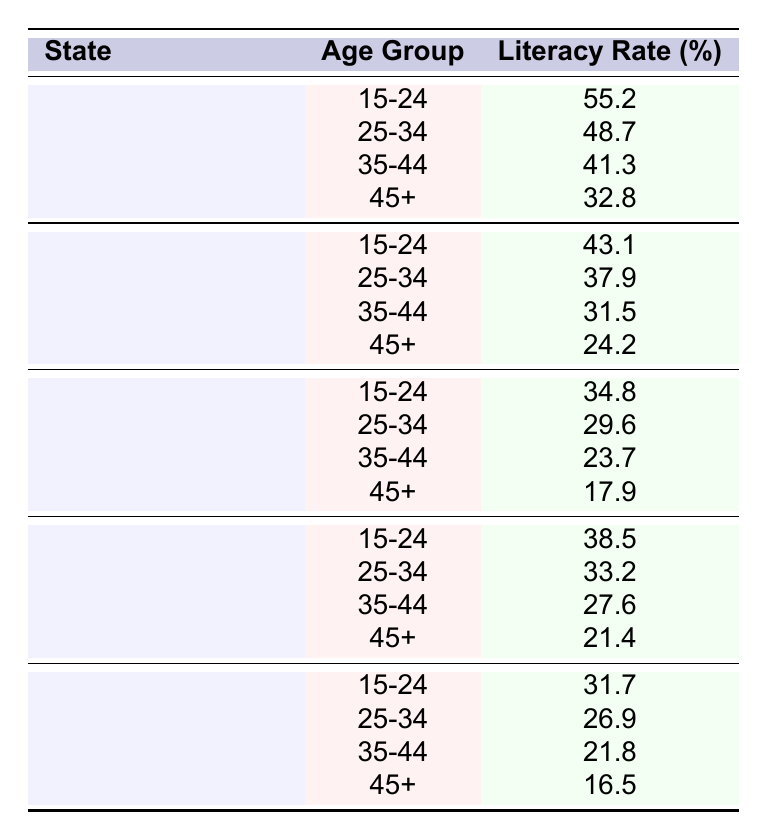What is the literacy rate for the age group 15-24 in Central Equatoria? According to the table, the literacy rate for the age group 15-24 in Central Equatoria is explicitly given as 55.2%.
Answer: 55.2% Which state has the highest literacy rate for the age group 25-34? By comparing the literacy rates for the age group 25-34 from all states, I observe that Central Equatoria has the highest rate at 48.7%.
Answer: Central Equatoria What is the literacy rate difference between the age groups 35-44 and 45+ in Western Equatoria? The literacy rate for age group 35-44 in Western Equatoria is 31.5%, and for 45+, it is 24.2%. The difference is calculated as 31.5 - 24.2 = 7.3%.
Answer: 7.3% Which state has the lowest literacy rate in the age group 45+? Jonglei has the lowest literacy rate for the age group 45+ at 17.9%.
Answer: Jonglei What is the average literacy rate for the age group 15-24 across all states? I calculate the average by adding the literacy rates for the age group 15-24: 55.2 (Central Equatoria) + 43.1 (Western Equatoria) + 34.8 (Jonglei) + 38.5 (Upper Nile) + 31.7 (Unity) = 203.3. Since there are 5 states, the average is 203.3 / 5 = 40.66%.
Answer: 40.66% Is the literacy rate for the age group 25-34 in Upper Nile greater than that in Jonglei? The literacy rate for 25-34 in Upper Nile is 33.2%, while in Jonglei it is 29.6%. Since 33.2 is greater than 29.6, the statement is true.
Answer: Yes What is the relationship between the literacy rates of age groups 15-24 and 45+ in Central Equatoria? The literacy rate for age group 15-24 in Central Equatoria is 55.2%, and for 45+, it is 32.8%. The rate in the younger group is significantly higher than in the older group, indicating that younger individuals are more literate.
Answer: Higher for 15-24 How does the literacy rate for the age group 35-44 in Unity compare to that in Upper Nile? The literacy rate for age group 35-44 in Unity is 21.8%, while in Upper Nile it is 27.6%. Since 21.8% is less than 27.6%, Unity has a lower literacy rate in this age group.
Answer: Lower in Unity 